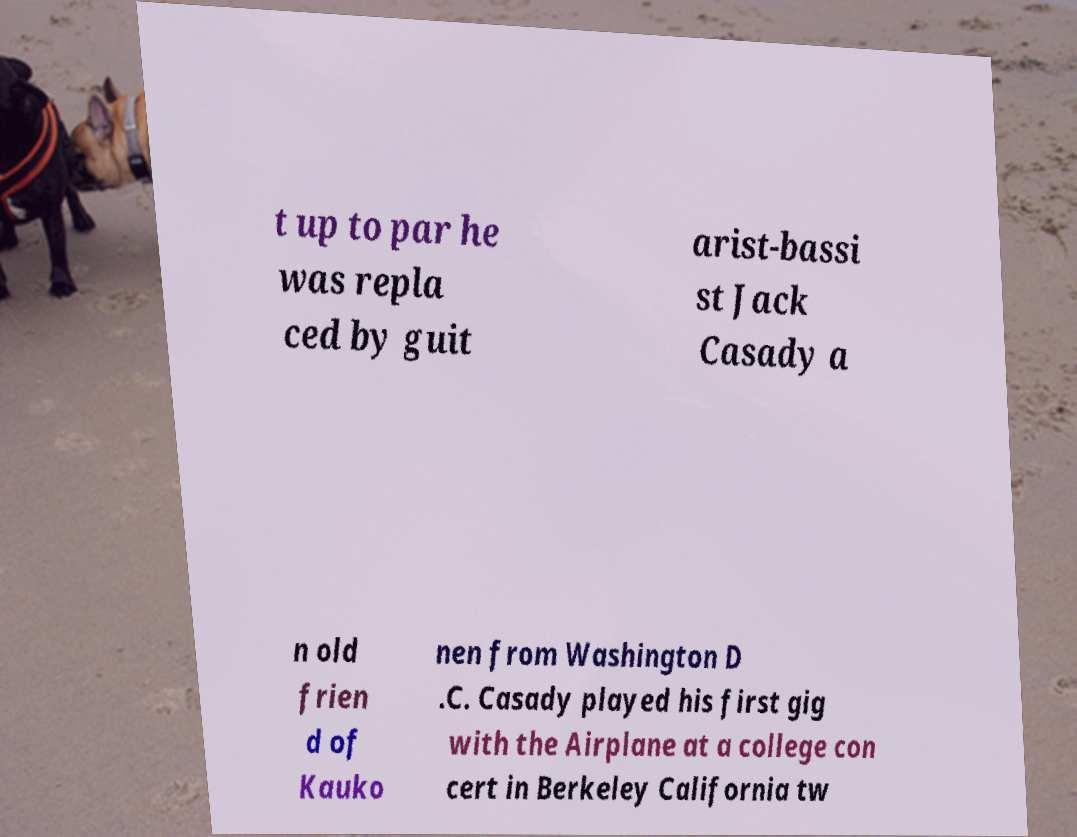Please identify and transcribe the text found in this image. t up to par he was repla ced by guit arist-bassi st Jack Casady a n old frien d of Kauko nen from Washington D .C. Casady played his first gig with the Airplane at a college con cert in Berkeley California tw 